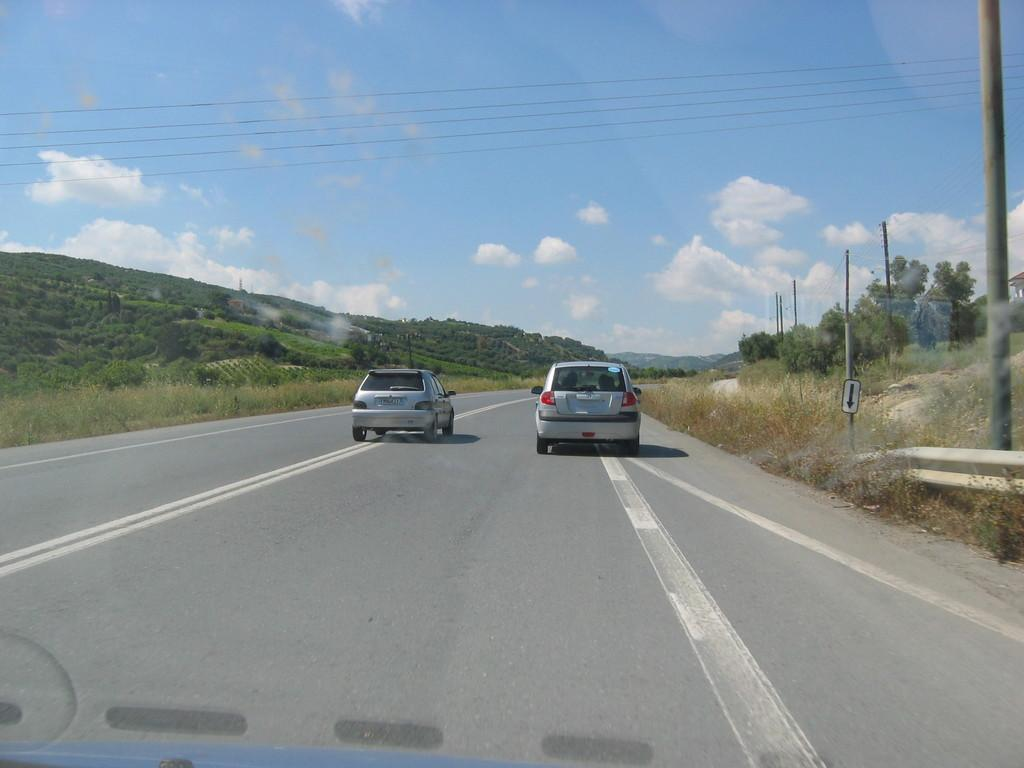What can be seen on the road in the image? There are cars on the road in the image. What type of vegetation is visible in the image? There is grass visible in the image. What objects can be seen in the image that are not related to the road or vegetation? There are piles, a sign board, wires, and a group of trees on the hills in the image. What is the condition of the sky in the image? The sky is visible in the image, and it looks cloudy. Can you tell me where your aunt and sister are in the image? There is no mention of an aunt or sister in the image, so we cannot determine their location. Is there a rail in the image? There is no rail present in the image. 